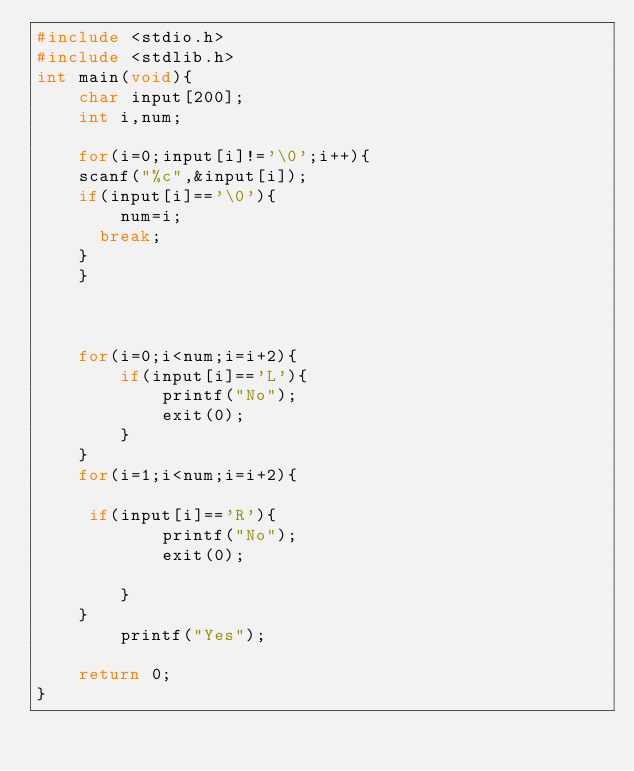Convert code to text. <code><loc_0><loc_0><loc_500><loc_500><_C_>#include <stdio.h>
#include <stdlib.h>
int main(void){
    char input[200];
    int i,num;
    
    for(i=0;input[i]!='\0';i++){
    scanf("%c",&input[i]);
    if(input[i]=='\0'){
        num=i;
      break;
    }
    }    
    
    
    
    for(i=0;i<num;i=i+2){
        if(input[i]=='L'){
            printf("No");
            exit(0);
        }
    }
    for(i=1;i<num;i=i+2){
        
     if(input[i]=='R'){
            printf("No");
            exit(0);
    
        }
    } 
        printf("Yes");
 
    return 0;
}
</code> 